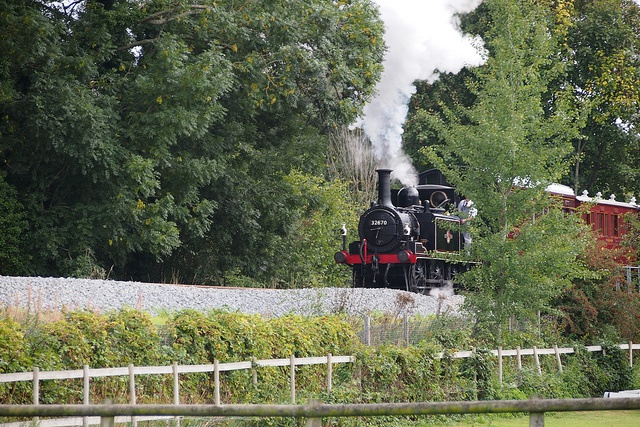Describe the objects in this image and their specific colors. I can see train in black, gray, maroon, and olive tones and people in black, gray, darkgray, and lightgray tones in this image. 